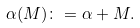Convert formula to latex. <formula><loc_0><loc_0><loc_500><loc_500>\alpha ( M ) \colon = \alpha + M .</formula> 